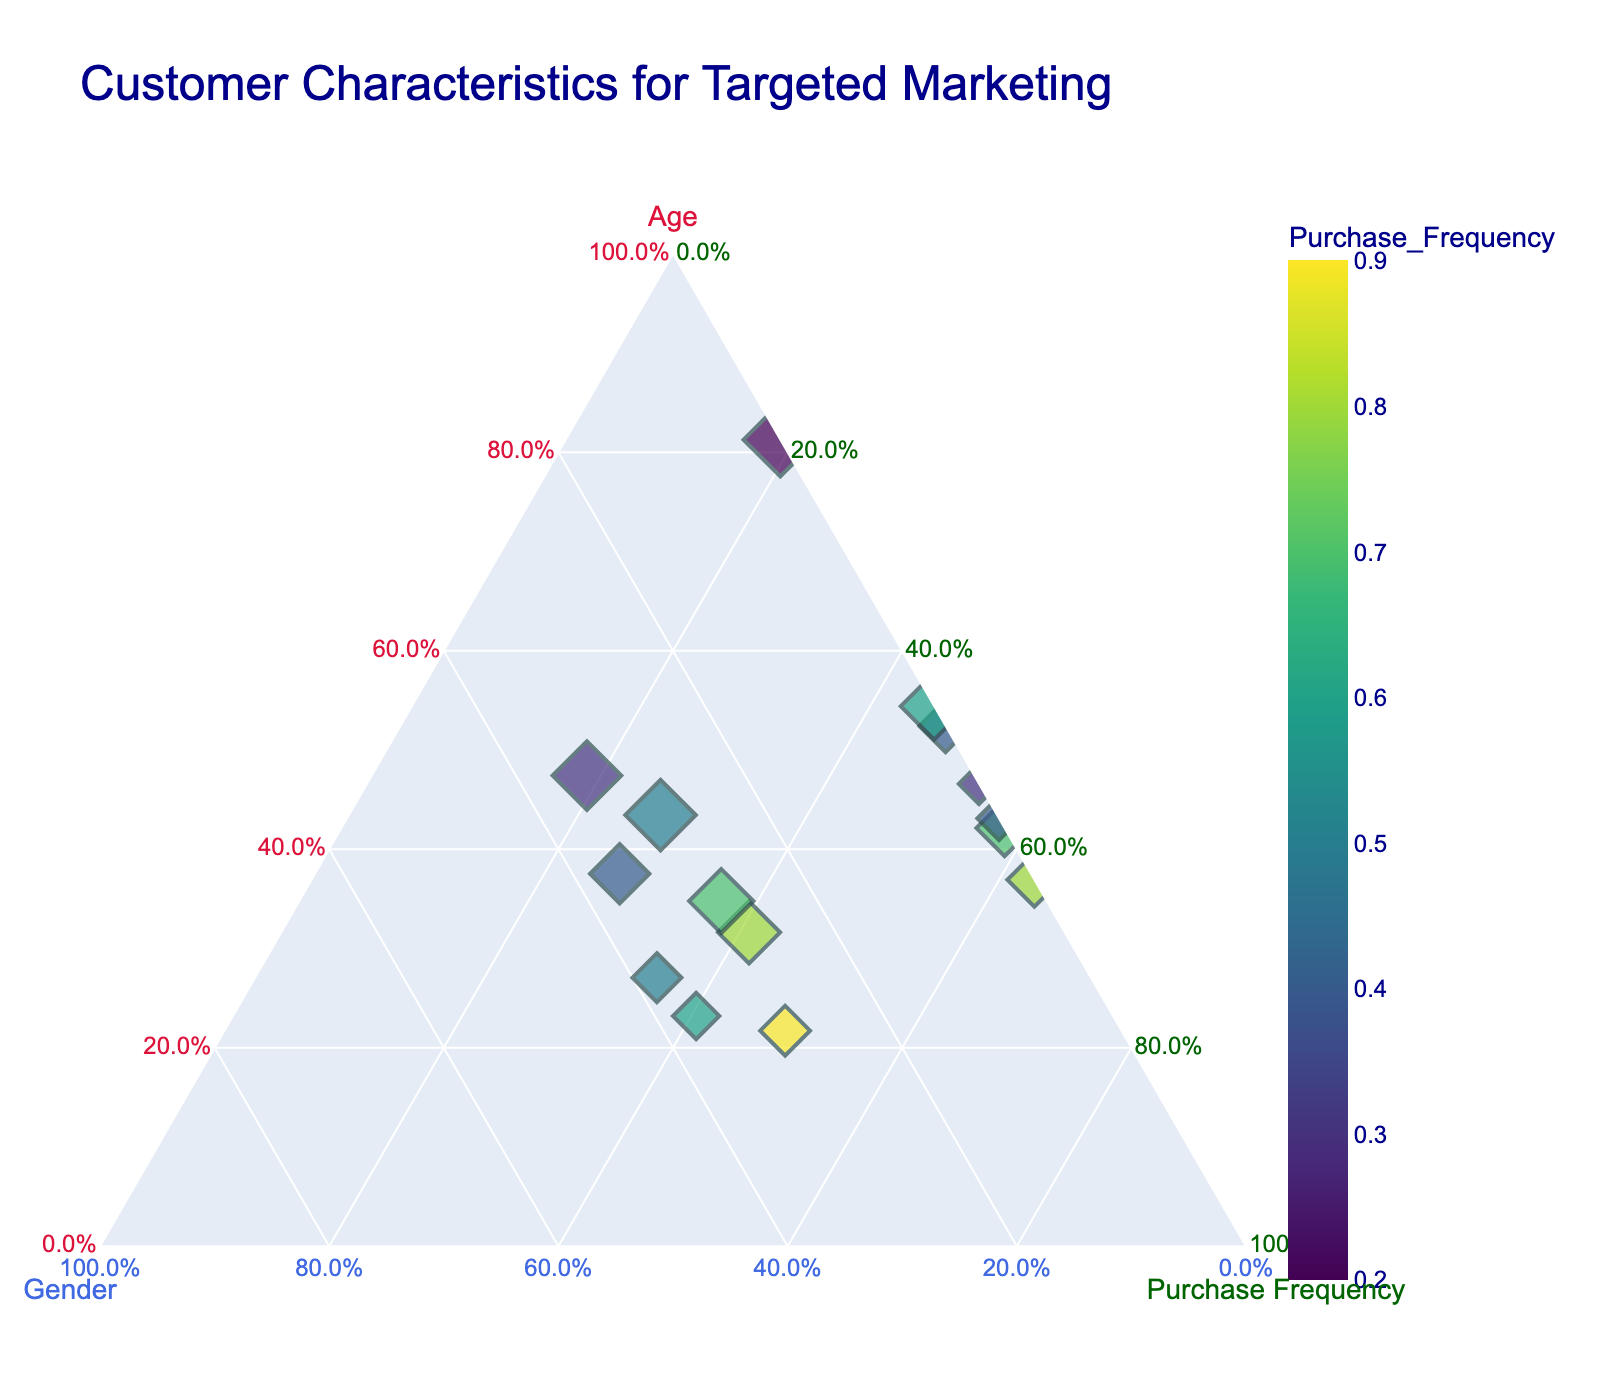What is the title of the figure? The title of the figure is shown at the top of the plot, typically in a larger and bold font.
Answer: Customer Characteristics for Targeted Marketing What are the colors used for the axis titles? The axis titles are color-coded: Age is crimson, Gender is royal blue, and Purchase Frequency is dark green.
Answer: Age: crimson, Gender: royal blue, Purchase Frequency: dark green How many data points are shown in the plot? By counting the points in the ternary plot, we can determine the total number of data points.
Answer: 15 Which data point has the highest purchase frequency? By looking at the plot, the point with the deepest color in the color scale (representing highest purchase frequency) corresponds to the highest purchase frequency value.
Answer: Female, Age 29 What is the general trend between Age and Purchase Frequency? Observing the plot, notice how the points are distributed with respect to the Age and Purchase Frequency axes. As age increases, purchase frequency doesn't show a clear linear pattern.
Answer: No clear linear trend Which gender is associated with higher purchase frequencies in the plot? By closely examining the color gradient and hovering over the gender data, typically females exhibit higher purchase frequencies than males.
Answer: Female How does the distribution of Purchase Frequency look with respect to Age? Assessing the color gradients visually across different age groups helps to establish the general pattern. Higher frequencies tend to appear sporadically in different age groups rather than uniformly.
Answer: Sporadic across ages If we look at the data points with age between 25 and 45, which gender tends to have higher purchase frequencies within this range? By focusing on data points within the specified age range and comparing the colors (purchase frequencies) between the genders, you can determine this.
Answer: Female Is there a consistent relationship between Purchase Frequency and Gender for individuals under 30? By looking at the purchase frequencies (color intensity) among individuals under 30 and their gender, one can analyze any consistent patterns.
Answer: Generally, females have higher purchase frequencies What is the normalized value for Gender represented in the ternary plot for males and females? Each data point's normalized values for Gender are plotted, where males are 0 and females are 0.0667 (since it’s 1 divided by the number of data points, 15).
Answer: Male: 0, Female: 0.0667 